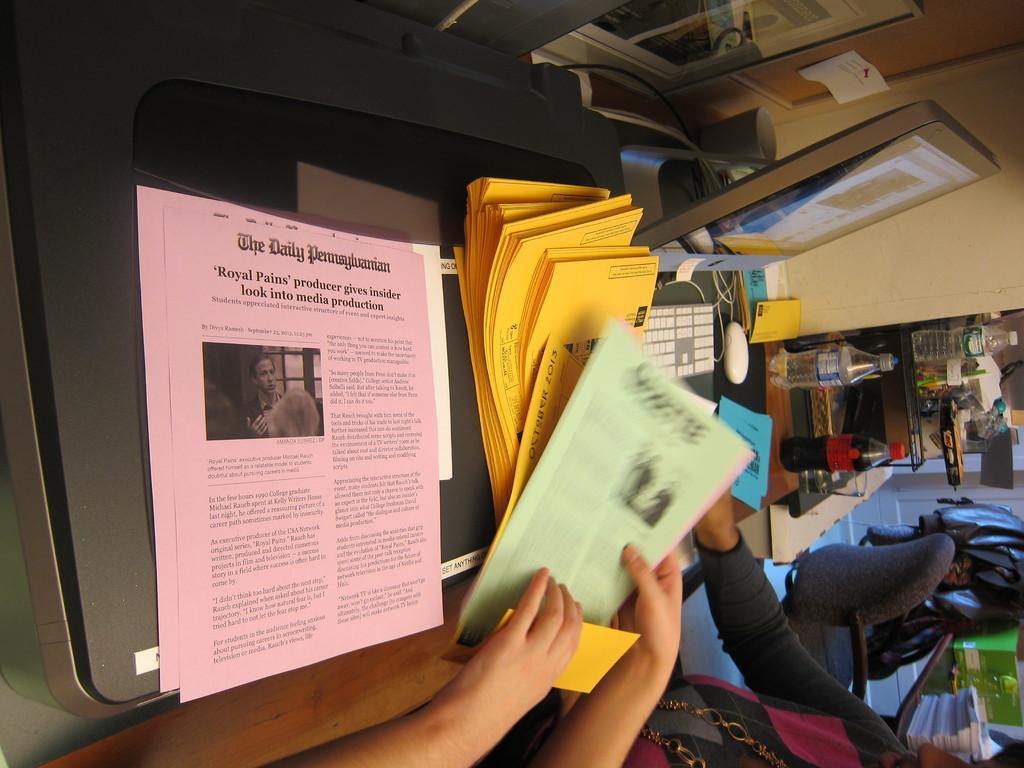In one or two sentences, can you explain what this image depicts? In this image there are people. In front of them there is a table. On top of it there is a computer, papers and a few other objects. On the right side of the image there is a chair. There is a table. On top of it there are books, box. In front of the table there is some object. There is another table. On top of it there are water bottles and a few other objects. In the background of the image there is a wall. 